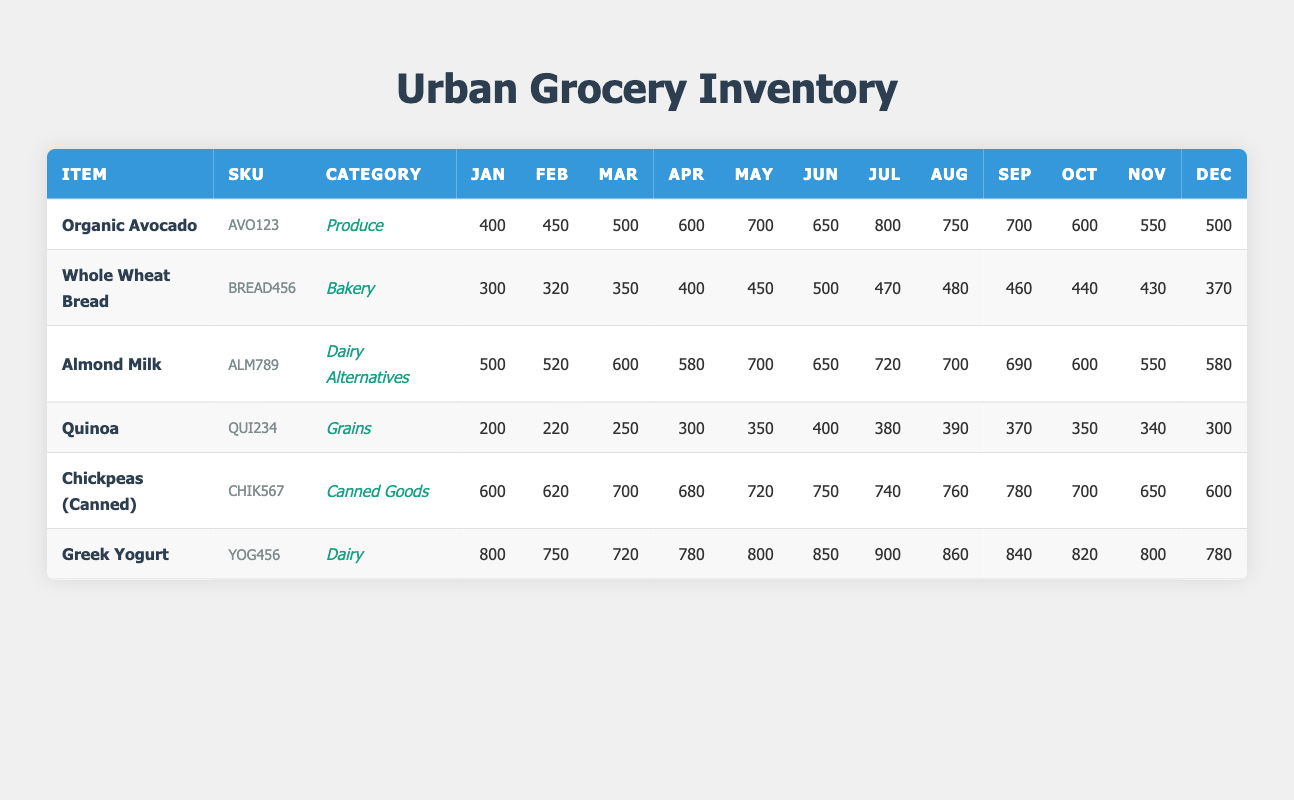What is the monthly stock level of Organic Avocado in July? According to the table, the stock level of Organic Avocado in July is 800.
Answer: 800 How much Whole Wheat Bread was stocked in November compared to October? The stock of Whole Wheat Bread in November is 430 and in October is 440. The difference is 440 - 430 = 10.
Answer: 10 Which item had the highest stock level in March? Looking at the table, Greek Yogurt has the highest stock level in March with 720.
Answer: 720 What is the total stock for Chickpeas (Canned) from January to March? Adding the stock levels for Chickpeas (Canned): January 600 + February 620 + March 700 results in a total of 600 + 620 + 700 = 1920.
Answer: 1920 Did the stock of Almond Milk decrease from June to October? In June, the stock is 650 and in October it is 600. Since 650 is greater than 600, the stock did decrease.
Answer: Yes What was the average monthly stock level of Quinoa for the first half of the year? The monthly stock levels for Quinoa from January to June are: 200, 220, 250, 300, 350, and 400. The total is 200 + 220 + 250 + 300 + 350 + 400 = 1720. Dividing by 6 gives an average of 1720 / 6 ≈ 286.67.
Answer: 286.67 Which item showed the largest increase in stock from January to July? The largest increase can be calculated by looking for the difference between January and July stock levels for each item. For Greek Yogurt, the increase is 900 - 800 = 100 in this period. For Organic Avocado, the increase is 800 - 400 = 400. Organic Avocado showed the largest increase.
Answer: Organic Avocado Did any item have higher stock levels in April compared to the following month, May? Looking at April stock levels: Organic Avocado (600), Whole Wheat Bread (400), Almond Milk (580), Quinoa (300), Chickpeas (680), Greek Yogurt (780). All of these levels are lower when compared to the stock in May, where Organic Avocado is 700, Whole Wheat Bread is 450, Almond Milk is 700, Quinoa is 350, Chickpeas are 720, and Greek Yogurt is 800. This means all stocks increased.
Answer: No 